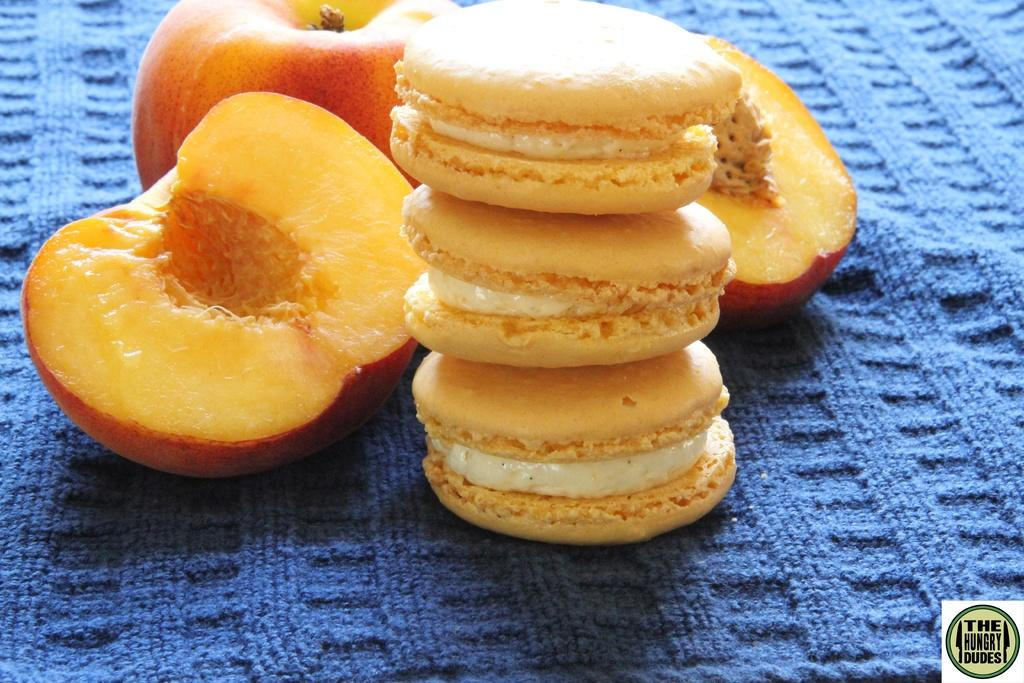What types of food items can be seen in the image? There are apples in the image, which are a type of food item. Can you describe the specific food item that is present in the image? Yes, there are apples in the image. What substance is being used to power the trains in the image? There are no trains present in the image, so it is not possible to determine what substance might be powering them. 